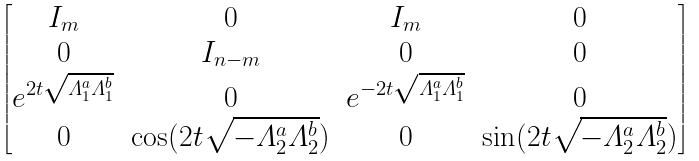<formula> <loc_0><loc_0><loc_500><loc_500>\begin{bmatrix} I _ { m } & 0 & I _ { m } & 0 \\ 0 & I _ { n - m } & 0 & 0 \\ e ^ { 2 t \sqrt { \varLambda _ { 1 } ^ { a } \varLambda _ { 1 } ^ { b } } } & 0 & e ^ { - 2 t \sqrt { \varLambda _ { 1 } ^ { a } \varLambda _ { 1 } ^ { b } } } & 0 \\ 0 & \cos ( 2 t \sqrt { - \varLambda _ { 2 } ^ { a } \varLambda _ { 2 } ^ { b } } ) & 0 & \sin ( 2 t \sqrt { - \varLambda _ { 2 } ^ { a } \varLambda _ { 2 } ^ { b } } ) \end{bmatrix}</formula> 